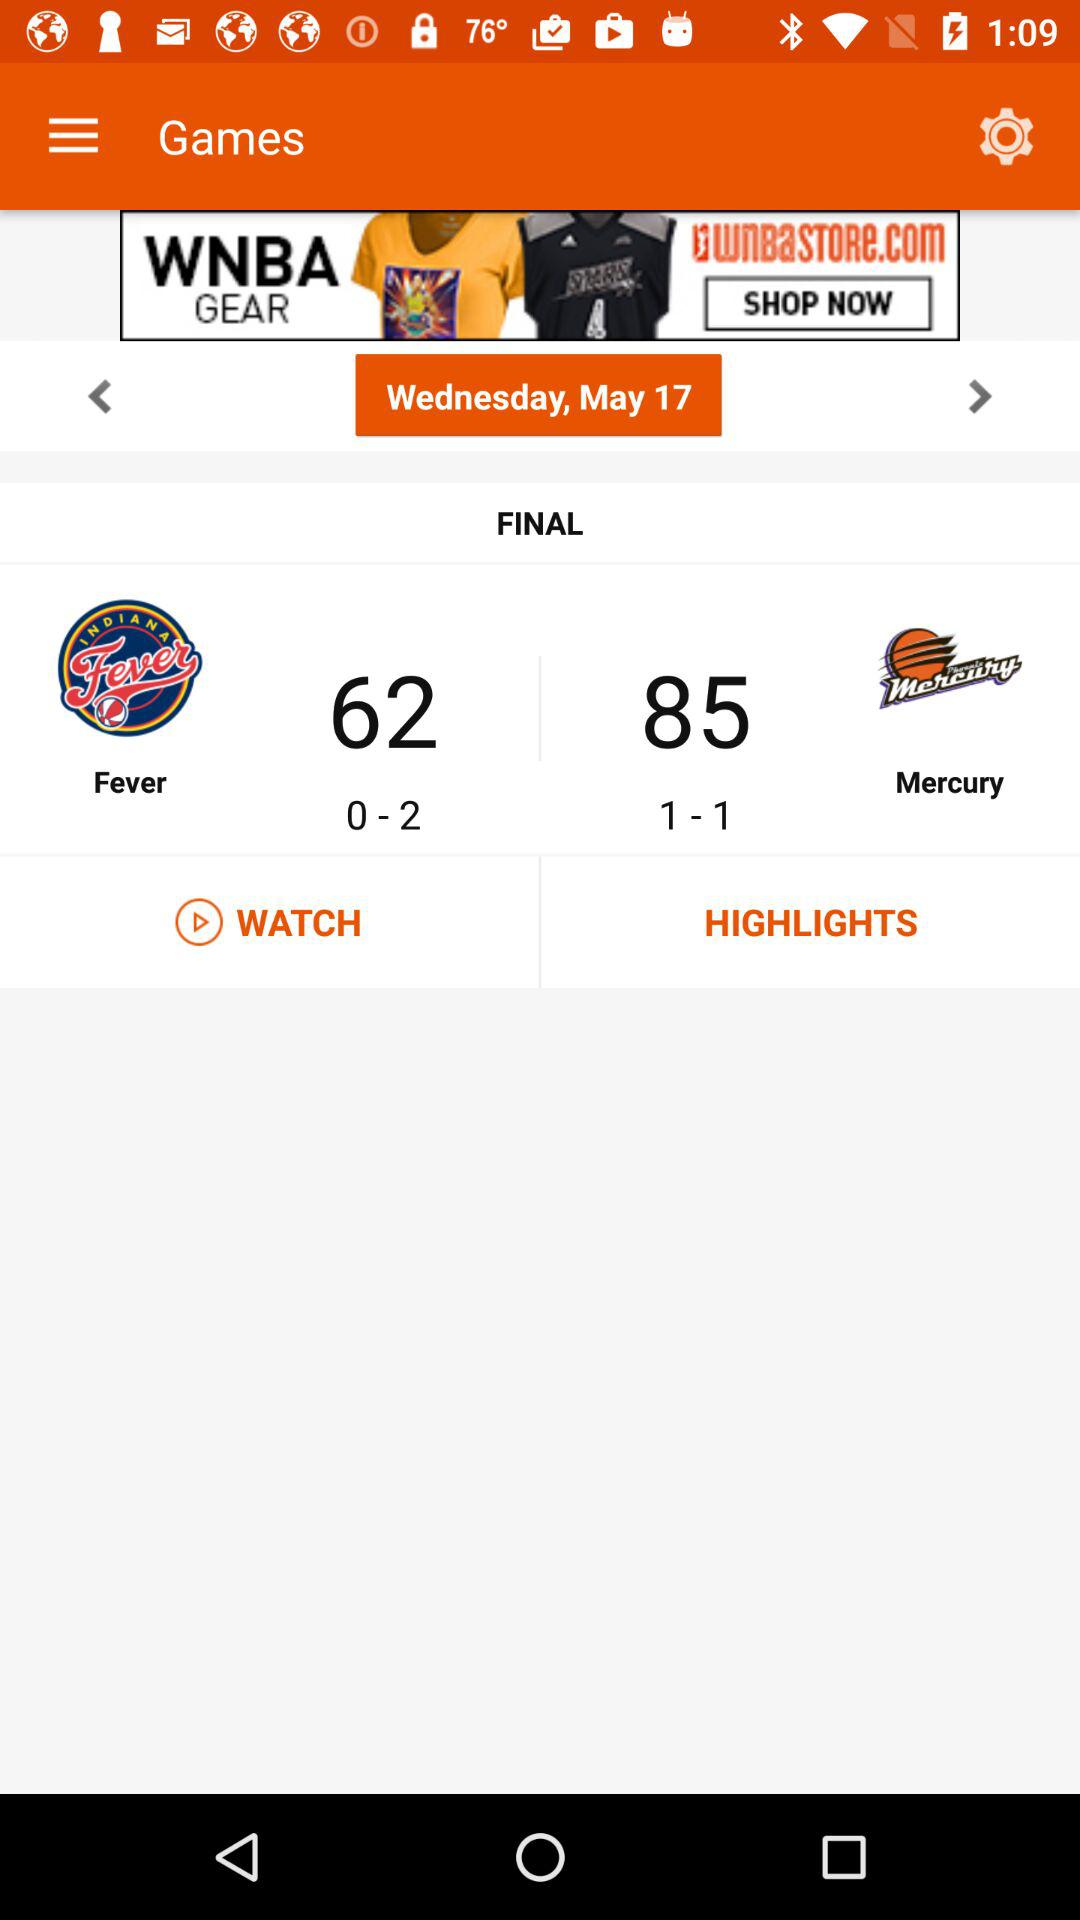How many games did the Fever win?
Answer the question using a single word or phrase. 0 